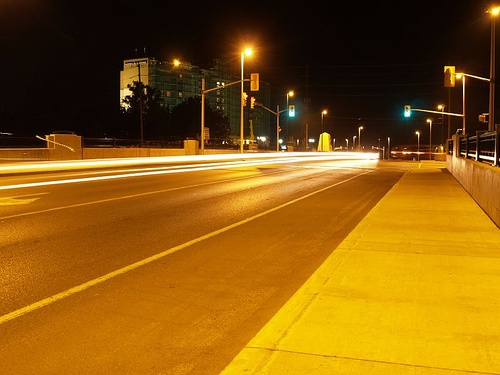Describe the objects in this image and their specific colors. I can see traffic light in maroon, gold, orange, and brown tones, car in maroon, brown, and tan tones, traffic light in maroon, orange, and red tones, traffic light in maroon, ivory, olive, tan, and teal tones, and traffic light in maroon, black, and orange tones in this image. 